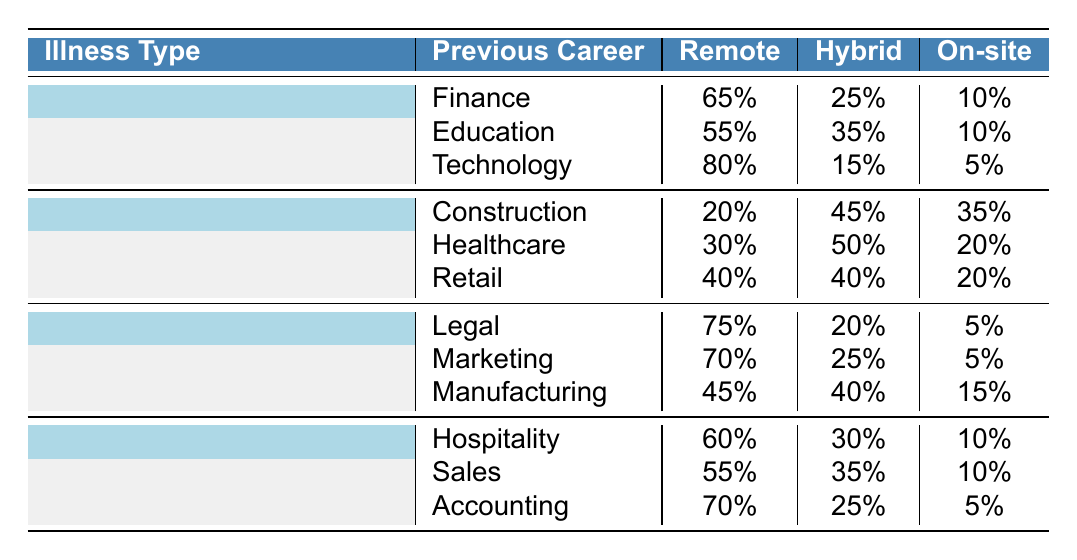What is the preferred work arrangement for Cancer patients in the Technology field? According to the table, for Cancer patients who worked in Technology, 80% prefer remote work, 15% prefer hybrid, and 5% prefer on-site. Thus, the preferred arrangement is remote.
Answer: Remote Which illness type shows the highest percentage of preference for hybrid work among previous career fields? Looking at the table, the highest hybrid preference is seen in the Healthcare field under Heart Disease, which has 50%.
Answer: Heart Disease What percentage of Cancer patients prefer on-site work? Analyzing the Cancer row, all previous career fields reported the following percentages for on-site work: Finance (10%), Education (10%), and Technology (5%). The average is (10 + 10 + 5) / 3 = 8.33%, but 10% is the maximum on-site preference.
Answer: 10% Which illness type and previous career field combination has the lowest percentage of remote work? By scanning through the table, the combination of Construction under Heart Disease has the lowest remote preference at 20%.
Answer: Heart Disease, Construction What is the total percentage of remote work preference among patients with Multiple Sclerosis in the Marketing and Legal fields? The table shows 75% for Marketing and 70% for Legal. Adding these gives 75 + 70 = 145%. To find the average, we divide by 2, so the total average remote preference among these fields is 145 / 2 = 72.5%.
Answer: 72.5% Do any patients with Chronic Fatigue Syndrome prefer only on-site work? The table indicates that for all previous career fields under Chronic Fatigue Syndrome (Hospitality, Sales, Accounting), the on-site preferences are none at 100%. This means no patients prefer exclusively on-site work.
Answer: No What is the preference for hybrid work in the Heart Disease category compared to Multiple Sclerosis? The hybrid preferences are as follows: Heart Disease (Construction 45%, Healthcare 50%, Retail 40%) averages to 45%. Under Multiple Sclerosis, the hybrid preferences are (Legal 20%, Marketing 25%, Manufacturing 40%), which averages to 28.33%. This shows Heart Disease has a higher average hybrid preference.
Answer: Heart Disease is higher Which previous career field for Cancer patients has the highest percentage of remote work? Reviewing the Cancer data, Technology has 80%, which is higher than Finance (65%) and Education (55%).
Answer: Technology How does the remote work preference for patients with Chronic Fatigue Syndrome in the Accounting field compare to those in the Healthcare field under Heart Disease? The remote preference for Accounting is 70%, while for Healthcare it is 30%. Comparing these, 70% is significantly greater than 30%.
Answer: 70% vs 30% Is it true that all patients with Multiple Sclerosis prefer less than 50% hybrid work? From the table, the hybrid preferences for Multiple Sclerosis are 20% (Legal), 25% (Marketing), and 40% (Manufacturing), which confirms all are indeed below 50%.
Answer: Yes 